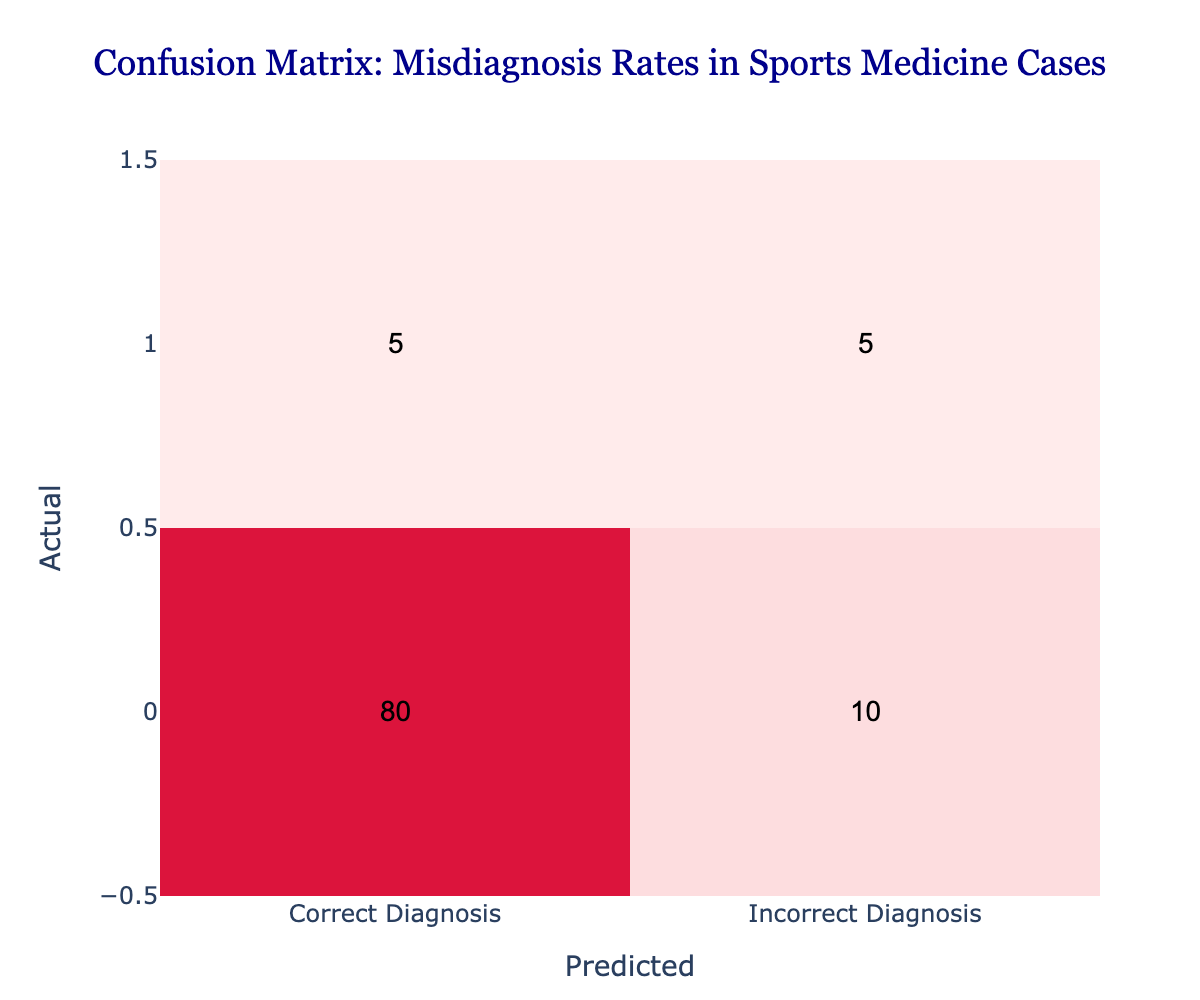What is the total number of cases diagnosed correctly? To find the total number of cases diagnosed correctly, look at the value in the "Correct Diagnosis" row under the "Correct Diagnosis" column, which is 80.
Answer: 80 What is the total number of cases diagnosed incorrectly? The total number of incorrectly diagnosed cases is the sum of the values in the "Incorrect Diagnosis" row: 5 (correctly predicted as incorrect) + 5 (incorrectly predicted) = 10.
Answer: 10 How many cases were misdiagnosed as incorrect? The number of cases that were misdiagnosed as incorrect corresponds to the value in the "Incorrect Diagnosis" row under the "Correct Diagnosis" column, which is 5.
Answer: 5 What percentage of cases were correctly diagnosed? To calculate the percentage of correctly diagnosed cases, take the value from the "Correct Diagnosis" row ("Correct Diagnosis" column) which is 80, and divide it by the total number of cases (80 + 10 + 5 + 5 = 100). This gives (80/100) * 100 = 80%.
Answer: 80% Is the number of incorrect diagnoses greater than the number of correctly diagnosed cases? The total number of incorrect diagnoses is 10, which is less than the total number of correctly diagnosed cases which is 80. So, this statement is false.
Answer: No What is the difference between the number of correct diagnoses and the number of misdiagnosed cases? The number of correct diagnoses is 80 and the number of misdiagnosed cases is from the "Incorrect Diagnosis" row under "Incorrect Diagnosis" which is 5. The difference is 80 - 5 = 75.
Answer: 75 If a patient receives an incorrect diagnosis, what is the chance they were misdiagnosed? The chance of misdiagnosis for a patient receiving an incorrect diagnosis can be calculated as the ratio of the number of cases that were misdiagnosed (5) to the total number of incorrect diagnoses (10). The probability is thus 5/10 = 0.5 (or 50%).
Answer: 50% What is the ratio of correct diagnoses to incorrect diagnoses? The ratio of correct diagnoses (80) to incorrect diagnoses (10) can be calculated by dividing the two: 80:10, which simplifies to 8:1.
Answer: 8:1 How many cases were correctly diagnosed amongst the total cases? The total number of cases is the sum of all values in the confusion matrix: (80 + 10 + 5 + 5) = 100. The number correctly diagnosed is 80 out of the total, giving the value directly from the matrix and confirming the overall accuracy.
Answer: 80 